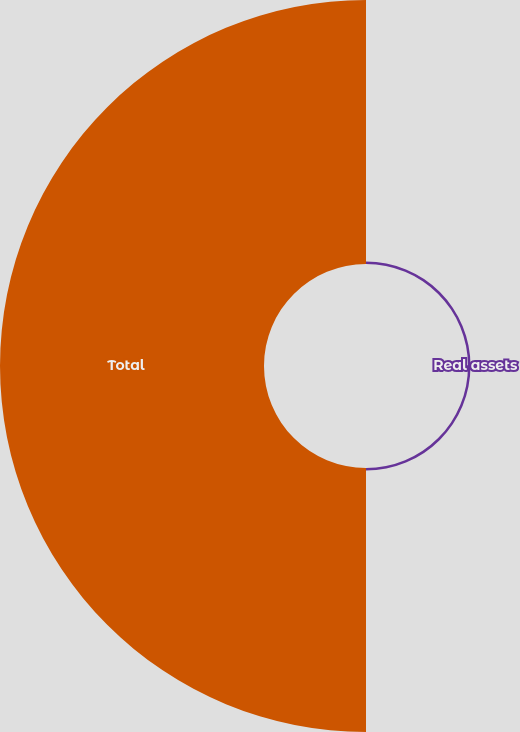Convert chart. <chart><loc_0><loc_0><loc_500><loc_500><pie_chart><fcel>Real assets<fcel>Total<nl><fcel>0.94%<fcel>99.06%<nl></chart> 